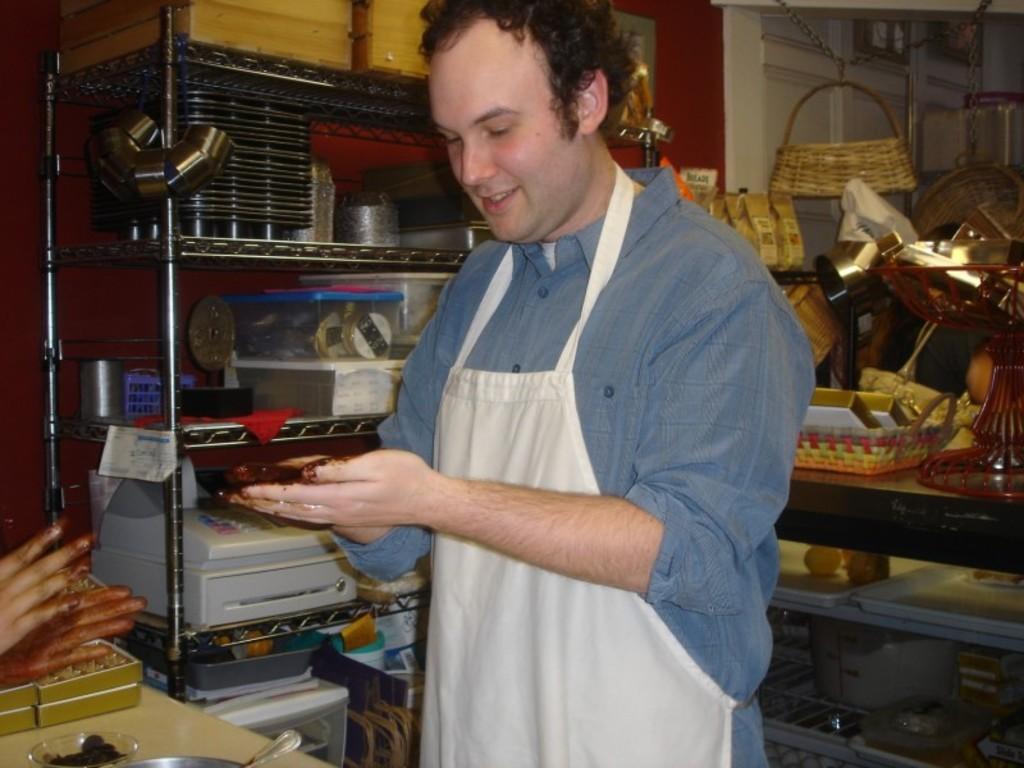How would you summarize this image in a sentence or two? In this image, we can see a person wearing an apron and smiling. On the left side of the image, we can see the hands of a person. At the bottom of the image, there are boxes, bowl and steel objects. In the background, we can see utensils, boxes, trays, baskets and some objects are placed on the shelves. We can see a maroon wall. On the right side of the image, there are baskets hanging with chains. 